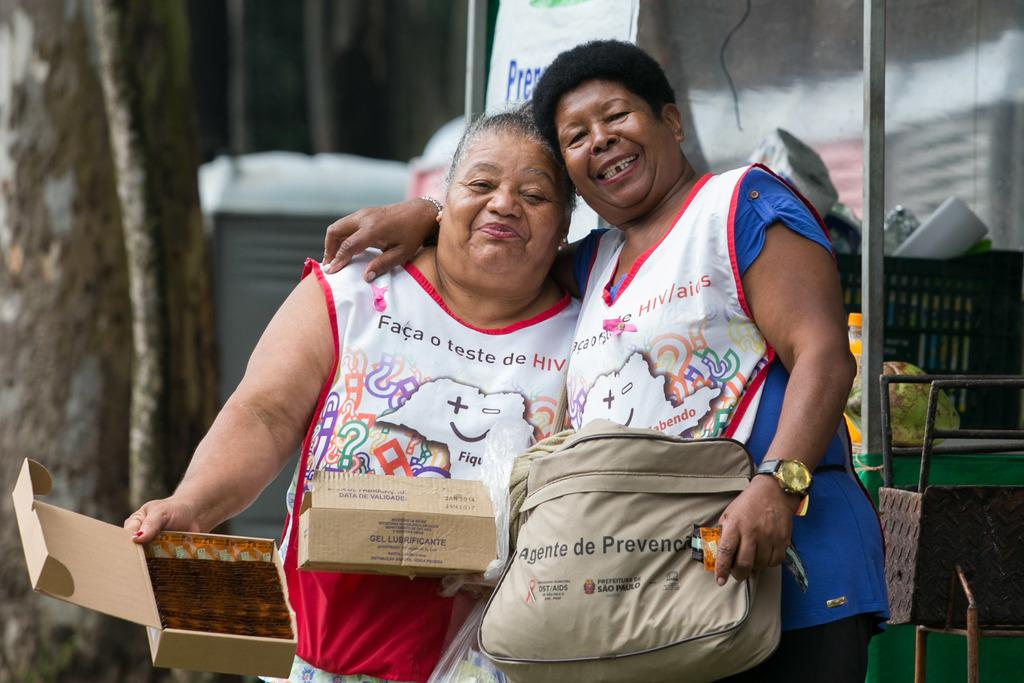<image>
Give a short and clear explanation of the subsequent image. a pair of women taking a picture together with one wearing an apron that says 'faca o teste de HIV' 